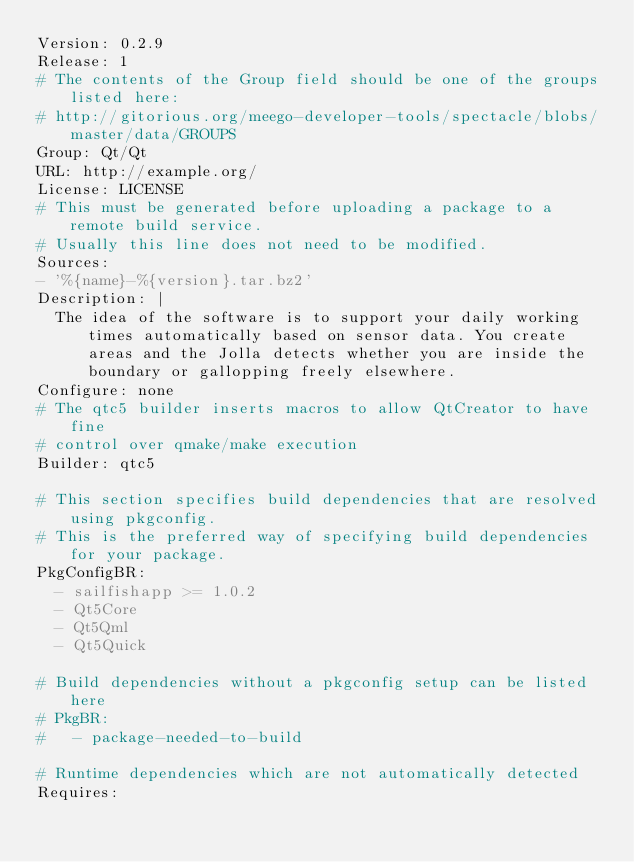Convert code to text. <code><loc_0><loc_0><loc_500><loc_500><_YAML_>Version: 0.2.9
Release: 1
# The contents of the Group field should be one of the groups listed here:
# http://gitorious.org/meego-developer-tools/spectacle/blobs/master/data/GROUPS
Group: Qt/Qt
URL: http://example.org/
License: LICENSE
# This must be generated before uploading a package to a remote build service.
# Usually this line does not need to be modified.
Sources:
- '%{name}-%{version}.tar.bz2'
Description: |
  The idea of the software is to support your daily working times automatically based on sensor data. You create areas and the Jolla detects whether you are inside the boundary or gallopping freely elsewhere.
Configure: none
# The qtc5 builder inserts macros to allow QtCreator to have fine
# control over qmake/make execution
Builder: qtc5

# This section specifies build dependencies that are resolved using pkgconfig.
# This is the preferred way of specifying build dependencies for your package.
PkgConfigBR:
  - sailfishapp >= 1.0.2
  - Qt5Core
  - Qt5Qml
  - Qt5Quick

# Build dependencies without a pkgconfig setup can be listed here
# PkgBR:
#   - package-needed-to-build

# Runtime dependencies which are not automatically detected
Requires:</code> 